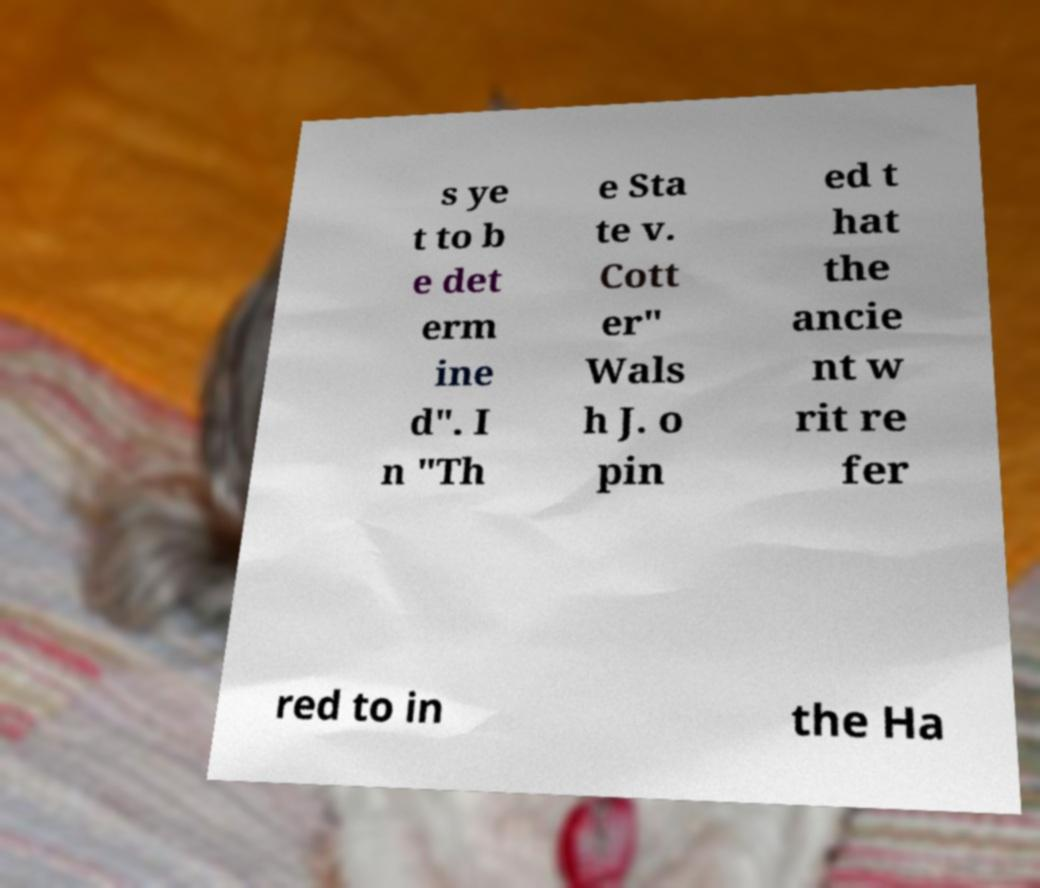For documentation purposes, I need the text within this image transcribed. Could you provide that? s ye t to b e det erm ine d". I n "Th e Sta te v. Cott er" Wals h J. o pin ed t hat the ancie nt w rit re fer red to in the Ha 